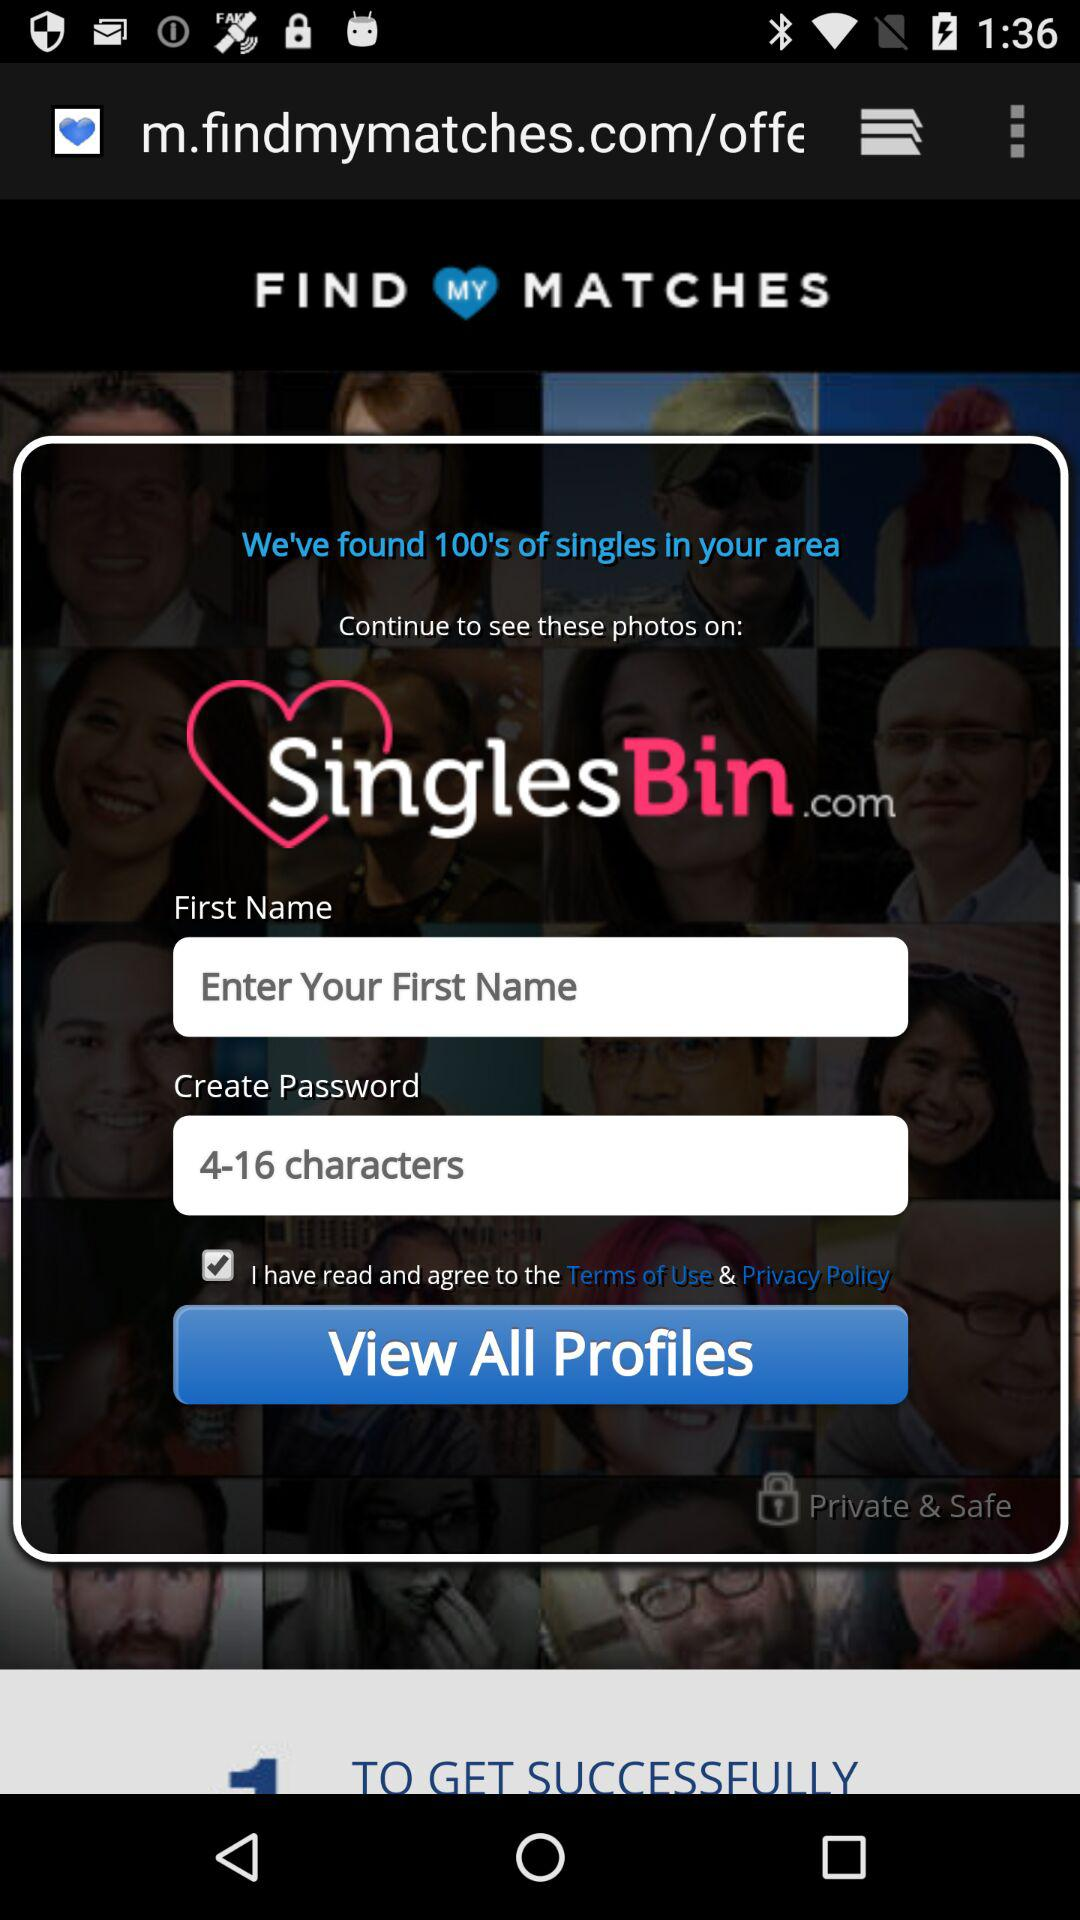What is the status of the option that includes agreement to the “Terms of Use” and “Privacy Policy”? The status is "on". 